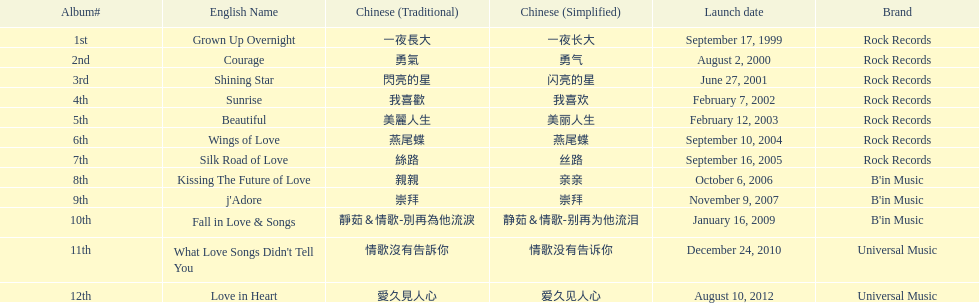Which was the only album to be released by b'in music in an even-numbered year? Kissing The Future of Love. 